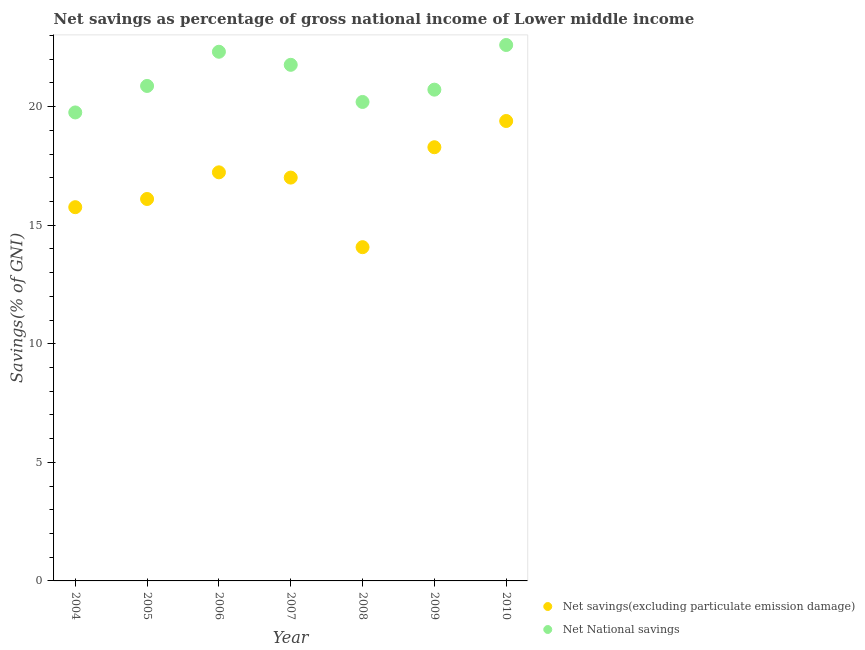What is the net national savings in 2005?
Your response must be concise. 20.87. Across all years, what is the maximum net savings(excluding particulate emission damage)?
Offer a very short reply. 19.4. Across all years, what is the minimum net national savings?
Provide a succinct answer. 19.76. In which year was the net national savings minimum?
Make the answer very short. 2004. What is the total net national savings in the graph?
Give a very brief answer. 148.23. What is the difference between the net national savings in 2007 and that in 2008?
Provide a succinct answer. 1.57. What is the difference between the net national savings in 2006 and the net savings(excluding particulate emission damage) in 2004?
Your response must be concise. 6.55. What is the average net national savings per year?
Make the answer very short. 21.18. In the year 2005, what is the difference between the net national savings and net savings(excluding particulate emission damage)?
Make the answer very short. 4.77. In how many years, is the net national savings greater than 14 %?
Give a very brief answer. 7. What is the ratio of the net savings(excluding particulate emission damage) in 2006 to that in 2010?
Your answer should be very brief. 0.89. Is the net savings(excluding particulate emission damage) in 2004 less than that in 2007?
Ensure brevity in your answer.  Yes. What is the difference between the highest and the second highest net savings(excluding particulate emission damage)?
Your answer should be very brief. 1.11. What is the difference between the highest and the lowest net savings(excluding particulate emission damage)?
Keep it short and to the point. 5.32. Does the net national savings monotonically increase over the years?
Make the answer very short. No. Is the net national savings strictly greater than the net savings(excluding particulate emission damage) over the years?
Keep it short and to the point. Yes. Is the net savings(excluding particulate emission damage) strictly less than the net national savings over the years?
Provide a succinct answer. Yes. How many dotlines are there?
Make the answer very short. 2. Are the values on the major ticks of Y-axis written in scientific E-notation?
Make the answer very short. No. How are the legend labels stacked?
Provide a short and direct response. Vertical. What is the title of the graph?
Your response must be concise. Net savings as percentage of gross national income of Lower middle income. Does "Export" appear as one of the legend labels in the graph?
Keep it short and to the point. No. What is the label or title of the X-axis?
Provide a succinct answer. Year. What is the label or title of the Y-axis?
Give a very brief answer. Savings(% of GNI). What is the Savings(% of GNI) of Net savings(excluding particulate emission damage) in 2004?
Your response must be concise. 15.76. What is the Savings(% of GNI) of Net National savings in 2004?
Provide a short and direct response. 19.76. What is the Savings(% of GNI) of Net savings(excluding particulate emission damage) in 2005?
Give a very brief answer. 16.11. What is the Savings(% of GNI) of Net National savings in 2005?
Make the answer very short. 20.87. What is the Savings(% of GNI) of Net savings(excluding particulate emission damage) in 2006?
Offer a very short reply. 17.23. What is the Savings(% of GNI) of Net National savings in 2006?
Your answer should be compact. 22.32. What is the Savings(% of GNI) in Net savings(excluding particulate emission damage) in 2007?
Ensure brevity in your answer.  17.01. What is the Savings(% of GNI) in Net National savings in 2007?
Your answer should be very brief. 21.76. What is the Savings(% of GNI) of Net savings(excluding particulate emission damage) in 2008?
Provide a short and direct response. 14.07. What is the Savings(% of GNI) of Net National savings in 2008?
Offer a very short reply. 20.2. What is the Savings(% of GNI) in Net savings(excluding particulate emission damage) in 2009?
Ensure brevity in your answer.  18.29. What is the Savings(% of GNI) in Net National savings in 2009?
Your answer should be compact. 20.72. What is the Savings(% of GNI) in Net savings(excluding particulate emission damage) in 2010?
Provide a succinct answer. 19.4. What is the Savings(% of GNI) of Net National savings in 2010?
Your response must be concise. 22.6. Across all years, what is the maximum Savings(% of GNI) in Net savings(excluding particulate emission damage)?
Your response must be concise. 19.4. Across all years, what is the maximum Savings(% of GNI) in Net National savings?
Keep it short and to the point. 22.6. Across all years, what is the minimum Savings(% of GNI) in Net savings(excluding particulate emission damage)?
Give a very brief answer. 14.07. Across all years, what is the minimum Savings(% of GNI) in Net National savings?
Give a very brief answer. 19.76. What is the total Savings(% of GNI) in Net savings(excluding particulate emission damage) in the graph?
Ensure brevity in your answer.  117.87. What is the total Savings(% of GNI) in Net National savings in the graph?
Your response must be concise. 148.23. What is the difference between the Savings(% of GNI) of Net savings(excluding particulate emission damage) in 2004 and that in 2005?
Provide a succinct answer. -0.35. What is the difference between the Savings(% of GNI) of Net National savings in 2004 and that in 2005?
Keep it short and to the point. -1.12. What is the difference between the Savings(% of GNI) in Net savings(excluding particulate emission damage) in 2004 and that in 2006?
Provide a short and direct response. -1.47. What is the difference between the Savings(% of GNI) in Net National savings in 2004 and that in 2006?
Give a very brief answer. -2.56. What is the difference between the Savings(% of GNI) of Net savings(excluding particulate emission damage) in 2004 and that in 2007?
Make the answer very short. -1.25. What is the difference between the Savings(% of GNI) in Net National savings in 2004 and that in 2007?
Give a very brief answer. -2.01. What is the difference between the Savings(% of GNI) in Net savings(excluding particulate emission damage) in 2004 and that in 2008?
Provide a succinct answer. 1.69. What is the difference between the Savings(% of GNI) in Net National savings in 2004 and that in 2008?
Give a very brief answer. -0.44. What is the difference between the Savings(% of GNI) in Net savings(excluding particulate emission damage) in 2004 and that in 2009?
Keep it short and to the point. -2.53. What is the difference between the Savings(% of GNI) of Net National savings in 2004 and that in 2009?
Give a very brief answer. -0.96. What is the difference between the Savings(% of GNI) in Net savings(excluding particulate emission damage) in 2004 and that in 2010?
Ensure brevity in your answer.  -3.63. What is the difference between the Savings(% of GNI) of Net National savings in 2004 and that in 2010?
Keep it short and to the point. -2.84. What is the difference between the Savings(% of GNI) in Net savings(excluding particulate emission damage) in 2005 and that in 2006?
Keep it short and to the point. -1.12. What is the difference between the Savings(% of GNI) in Net National savings in 2005 and that in 2006?
Offer a very short reply. -1.44. What is the difference between the Savings(% of GNI) in Net savings(excluding particulate emission damage) in 2005 and that in 2007?
Give a very brief answer. -0.9. What is the difference between the Savings(% of GNI) of Net National savings in 2005 and that in 2007?
Your response must be concise. -0.89. What is the difference between the Savings(% of GNI) in Net savings(excluding particulate emission damage) in 2005 and that in 2008?
Give a very brief answer. 2.03. What is the difference between the Savings(% of GNI) in Net National savings in 2005 and that in 2008?
Make the answer very short. 0.68. What is the difference between the Savings(% of GNI) of Net savings(excluding particulate emission damage) in 2005 and that in 2009?
Provide a short and direct response. -2.18. What is the difference between the Savings(% of GNI) of Net National savings in 2005 and that in 2009?
Give a very brief answer. 0.16. What is the difference between the Savings(% of GNI) of Net savings(excluding particulate emission damage) in 2005 and that in 2010?
Give a very brief answer. -3.29. What is the difference between the Savings(% of GNI) of Net National savings in 2005 and that in 2010?
Ensure brevity in your answer.  -1.73. What is the difference between the Savings(% of GNI) of Net savings(excluding particulate emission damage) in 2006 and that in 2007?
Keep it short and to the point. 0.22. What is the difference between the Savings(% of GNI) of Net National savings in 2006 and that in 2007?
Your answer should be compact. 0.55. What is the difference between the Savings(% of GNI) of Net savings(excluding particulate emission damage) in 2006 and that in 2008?
Keep it short and to the point. 3.16. What is the difference between the Savings(% of GNI) of Net National savings in 2006 and that in 2008?
Offer a very short reply. 2.12. What is the difference between the Savings(% of GNI) of Net savings(excluding particulate emission damage) in 2006 and that in 2009?
Provide a succinct answer. -1.06. What is the difference between the Savings(% of GNI) in Net National savings in 2006 and that in 2009?
Ensure brevity in your answer.  1.6. What is the difference between the Savings(% of GNI) of Net savings(excluding particulate emission damage) in 2006 and that in 2010?
Give a very brief answer. -2.16. What is the difference between the Savings(% of GNI) in Net National savings in 2006 and that in 2010?
Offer a terse response. -0.29. What is the difference between the Savings(% of GNI) of Net savings(excluding particulate emission damage) in 2007 and that in 2008?
Provide a succinct answer. 2.93. What is the difference between the Savings(% of GNI) of Net National savings in 2007 and that in 2008?
Your response must be concise. 1.57. What is the difference between the Savings(% of GNI) in Net savings(excluding particulate emission damage) in 2007 and that in 2009?
Keep it short and to the point. -1.28. What is the difference between the Savings(% of GNI) of Net National savings in 2007 and that in 2009?
Your answer should be very brief. 1.05. What is the difference between the Savings(% of GNI) in Net savings(excluding particulate emission damage) in 2007 and that in 2010?
Offer a very short reply. -2.39. What is the difference between the Savings(% of GNI) of Net National savings in 2007 and that in 2010?
Your response must be concise. -0.84. What is the difference between the Savings(% of GNI) of Net savings(excluding particulate emission damage) in 2008 and that in 2009?
Offer a very short reply. -4.21. What is the difference between the Savings(% of GNI) in Net National savings in 2008 and that in 2009?
Your answer should be compact. -0.52. What is the difference between the Savings(% of GNI) in Net savings(excluding particulate emission damage) in 2008 and that in 2010?
Offer a terse response. -5.32. What is the difference between the Savings(% of GNI) of Net National savings in 2008 and that in 2010?
Ensure brevity in your answer.  -2.4. What is the difference between the Savings(% of GNI) in Net savings(excluding particulate emission damage) in 2009 and that in 2010?
Offer a very short reply. -1.11. What is the difference between the Savings(% of GNI) of Net National savings in 2009 and that in 2010?
Offer a terse response. -1.88. What is the difference between the Savings(% of GNI) of Net savings(excluding particulate emission damage) in 2004 and the Savings(% of GNI) of Net National savings in 2005?
Provide a short and direct response. -5.11. What is the difference between the Savings(% of GNI) of Net savings(excluding particulate emission damage) in 2004 and the Savings(% of GNI) of Net National savings in 2006?
Give a very brief answer. -6.55. What is the difference between the Savings(% of GNI) in Net savings(excluding particulate emission damage) in 2004 and the Savings(% of GNI) in Net National savings in 2007?
Keep it short and to the point. -6. What is the difference between the Savings(% of GNI) of Net savings(excluding particulate emission damage) in 2004 and the Savings(% of GNI) of Net National savings in 2008?
Your answer should be very brief. -4.44. What is the difference between the Savings(% of GNI) of Net savings(excluding particulate emission damage) in 2004 and the Savings(% of GNI) of Net National savings in 2009?
Offer a terse response. -4.96. What is the difference between the Savings(% of GNI) of Net savings(excluding particulate emission damage) in 2004 and the Savings(% of GNI) of Net National savings in 2010?
Offer a very short reply. -6.84. What is the difference between the Savings(% of GNI) of Net savings(excluding particulate emission damage) in 2005 and the Savings(% of GNI) of Net National savings in 2006?
Provide a short and direct response. -6.21. What is the difference between the Savings(% of GNI) in Net savings(excluding particulate emission damage) in 2005 and the Savings(% of GNI) in Net National savings in 2007?
Make the answer very short. -5.66. What is the difference between the Savings(% of GNI) of Net savings(excluding particulate emission damage) in 2005 and the Savings(% of GNI) of Net National savings in 2008?
Keep it short and to the point. -4.09. What is the difference between the Savings(% of GNI) in Net savings(excluding particulate emission damage) in 2005 and the Savings(% of GNI) in Net National savings in 2009?
Provide a succinct answer. -4.61. What is the difference between the Savings(% of GNI) in Net savings(excluding particulate emission damage) in 2005 and the Savings(% of GNI) in Net National savings in 2010?
Provide a succinct answer. -6.49. What is the difference between the Savings(% of GNI) of Net savings(excluding particulate emission damage) in 2006 and the Savings(% of GNI) of Net National savings in 2007?
Your response must be concise. -4.53. What is the difference between the Savings(% of GNI) of Net savings(excluding particulate emission damage) in 2006 and the Savings(% of GNI) of Net National savings in 2008?
Ensure brevity in your answer.  -2.97. What is the difference between the Savings(% of GNI) of Net savings(excluding particulate emission damage) in 2006 and the Savings(% of GNI) of Net National savings in 2009?
Offer a terse response. -3.49. What is the difference between the Savings(% of GNI) in Net savings(excluding particulate emission damage) in 2006 and the Savings(% of GNI) in Net National savings in 2010?
Your answer should be compact. -5.37. What is the difference between the Savings(% of GNI) in Net savings(excluding particulate emission damage) in 2007 and the Savings(% of GNI) in Net National savings in 2008?
Keep it short and to the point. -3.19. What is the difference between the Savings(% of GNI) in Net savings(excluding particulate emission damage) in 2007 and the Savings(% of GNI) in Net National savings in 2009?
Offer a terse response. -3.71. What is the difference between the Savings(% of GNI) of Net savings(excluding particulate emission damage) in 2007 and the Savings(% of GNI) of Net National savings in 2010?
Provide a short and direct response. -5.59. What is the difference between the Savings(% of GNI) of Net savings(excluding particulate emission damage) in 2008 and the Savings(% of GNI) of Net National savings in 2009?
Offer a terse response. -6.64. What is the difference between the Savings(% of GNI) of Net savings(excluding particulate emission damage) in 2008 and the Savings(% of GNI) of Net National savings in 2010?
Offer a very short reply. -8.53. What is the difference between the Savings(% of GNI) in Net savings(excluding particulate emission damage) in 2009 and the Savings(% of GNI) in Net National savings in 2010?
Your answer should be compact. -4.31. What is the average Savings(% of GNI) in Net savings(excluding particulate emission damage) per year?
Give a very brief answer. 16.84. What is the average Savings(% of GNI) of Net National savings per year?
Make the answer very short. 21.18. In the year 2004, what is the difference between the Savings(% of GNI) in Net savings(excluding particulate emission damage) and Savings(% of GNI) in Net National savings?
Keep it short and to the point. -4. In the year 2005, what is the difference between the Savings(% of GNI) of Net savings(excluding particulate emission damage) and Savings(% of GNI) of Net National savings?
Your answer should be very brief. -4.77. In the year 2006, what is the difference between the Savings(% of GNI) of Net savings(excluding particulate emission damage) and Savings(% of GNI) of Net National savings?
Offer a very short reply. -5.08. In the year 2007, what is the difference between the Savings(% of GNI) in Net savings(excluding particulate emission damage) and Savings(% of GNI) in Net National savings?
Offer a terse response. -4.76. In the year 2008, what is the difference between the Savings(% of GNI) in Net savings(excluding particulate emission damage) and Savings(% of GNI) in Net National savings?
Offer a terse response. -6.12. In the year 2009, what is the difference between the Savings(% of GNI) of Net savings(excluding particulate emission damage) and Savings(% of GNI) of Net National savings?
Your answer should be compact. -2.43. In the year 2010, what is the difference between the Savings(% of GNI) in Net savings(excluding particulate emission damage) and Savings(% of GNI) in Net National savings?
Provide a succinct answer. -3.21. What is the ratio of the Savings(% of GNI) of Net savings(excluding particulate emission damage) in 2004 to that in 2005?
Offer a terse response. 0.98. What is the ratio of the Savings(% of GNI) in Net National savings in 2004 to that in 2005?
Give a very brief answer. 0.95. What is the ratio of the Savings(% of GNI) of Net savings(excluding particulate emission damage) in 2004 to that in 2006?
Offer a terse response. 0.91. What is the ratio of the Savings(% of GNI) of Net National savings in 2004 to that in 2006?
Provide a short and direct response. 0.89. What is the ratio of the Savings(% of GNI) in Net savings(excluding particulate emission damage) in 2004 to that in 2007?
Your answer should be very brief. 0.93. What is the ratio of the Savings(% of GNI) of Net National savings in 2004 to that in 2007?
Offer a very short reply. 0.91. What is the ratio of the Savings(% of GNI) in Net savings(excluding particulate emission damage) in 2004 to that in 2008?
Your answer should be very brief. 1.12. What is the ratio of the Savings(% of GNI) in Net National savings in 2004 to that in 2008?
Offer a terse response. 0.98. What is the ratio of the Savings(% of GNI) of Net savings(excluding particulate emission damage) in 2004 to that in 2009?
Your answer should be compact. 0.86. What is the ratio of the Savings(% of GNI) of Net National savings in 2004 to that in 2009?
Offer a very short reply. 0.95. What is the ratio of the Savings(% of GNI) of Net savings(excluding particulate emission damage) in 2004 to that in 2010?
Offer a very short reply. 0.81. What is the ratio of the Savings(% of GNI) in Net National savings in 2004 to that in 2010?
Ensure brevity in your answer.  0.87. What is the ratio of the Savings(% of GNI) in Net savings(excluding particulate emission damage) in 2005 to that in 2006?
Your answer should be compact. 0.93. What is the ratio of the Savings(% of GNI) in Net National savings in 2005 to that in 2006?
Keep it short and to the point. 0.94. What is the ratio of the Savings(% of GNI) in Net savings(excluding particulate emission damage) in 2005 to that in 2007?
Your response must be concise. 0.95. What is the ratio of the Savings(% of GNI) of Net National savings in 2005 to that in 2007?
Your answer should be very brief. 0.96. What is the ratio of the Savings(% of GNI) of Net savings(excluding particulate emission damage) in 2005 to that in 2008?
Keep it short and to the point. 1.14. What is the ratio of the Savings(% of GNI) in Net National savings in 2005 to that in 2008?
Make the answer very short. 1.03. What is the ratio of the Savings(% of GNI) in Net savings(excluding particulate emission damage) in 2005 to that in 2009?
Keep it short and to the point. 0.88. What is the ratio of the Savings(% of GNI) in Net National savings in 2005 to that in 2009?
Your answer should be very brief. 1.01. What is the ratio of the Savings(% of GNI) in Net savings(excluding particulate emission damage) in 2005 to that in 2010?
Your response must be concise. 0.83. What is the ratio of the Savings(% of GNI) in Net National savings in 2005 to that in 2010?
Your answer should be compact. 0.92. What is the ratio of the Savings(% of GNI) in Net savings(excluding particulate emission damage) in 2006 to that in 2007?
Keep it short and to the point. 1.01. What is the ratio of the Savings(% of GNI) in Net National savings in 2006 to that in 2007?
Provide a succinct answer. 1.03. What is the ratio of the Savings(% of GNI) of Net savings(excluding particulate emission damage) in 2006 to that in 2008?
Offer a terse response. 1.22. What is the ratio of the Savings(% of GNI) of Net National savings in 2006 to that in 2008?
Provide a short and direct response. 1.1. What is the ratio of the Savings(% of GNI) in Net savings(excluding particulate emission damage) in 2006 to that in 2009?
Ensure brevity in your answer.  0.94. What is the ratio of the Savings(% of GNI) of Net National savings in 2006 to that in 2009?
Make the answer very short. 1.08. What is the ratio of the Savings(% of GNI) of Net savings(excluding particulate emission damage) in 2006 to that in 2010?
Offer a very short reply. 0.89. What is the ratio of the Savings(% of GNI) of Net National savings in 2006 to that in 2010?
Ensure brevity in your answer.  0.99. What is the ratio of the Savings(% of GNI) of Net savings(excluding particulate emission damage) in 2007 to that in 2008?
Give a very brief answer. 1.21. What is the ratio of the Savings(% of GNI) in Net National savings in 2007 to that in 2008?
Offer a very short reply. 1.08. What is the ratio of the Savings(% of GNI) of Net savings(excluding particulate emission damage) in 2007 to that in 2009?
Keep it short and to the point. 0.93. What is the ratio of the Savings(% of GNI) of Net National savings in 2007 to that in 2009?
Offer a very short reply. 1.05. What is the ratio of the Savings(% of GNI) of Net savings(excluding particulate emission damage) in 2007 to that in 2010?
Make the answer very short. 0.88. What is the ratio of the Savings(% of GNI) of Net National savings in 2007 to that in 2010?
Offer a terse response. 0.96. What is the ratio of the Savings(% of GNI) of Net savings(excluding particulate emission damage) in 2008 to that in 2009?
Provide a short and direct response. 0.77. What is the ratio of the Savings(% of GNI) in Net National savings in 2008 to that in 2009?
Give a very brief answer. 0.97. What is the ratio of the Savings(% of GNI) of Net savings(excluding particulate emission damage) in 2008 to that in 2010?
Your answer should be compact. 0.73. What is the ratio of the Savings(% of GNI) in Net National savings in 2008 to that in 2010?
Provide a succinct answer. 0.89. What is the ratio of the Savings(% of GNI) of Net savings(excluding particulate emission damage) in 2009 to that in 2010?
Your response must be concise. 0.94. What is the ratio of the Savings(% of GNI) of Net National savings in 2009 to that in 2010?
Give a very brief answer. 0.92. What is the difference between the highest and the second highest Savings(% of GNI) in Net savings(excluding particulate emission damage)?
Ensure brevity in your answer.  1.11. What is the difference between the highest and the second highest Savings(% of GNI) in Net National savings?
Your response must be concise. 0.29. What is the difference between the highest and the lowest Savings(% of GNI) in Net savings(excluding particulate emission damage)?
Give a very brief answer. 5.32. What is the difference between the highest and the lowest Savings(% of GNI) in Net National savings?
Your response must be concise. 2.84. 